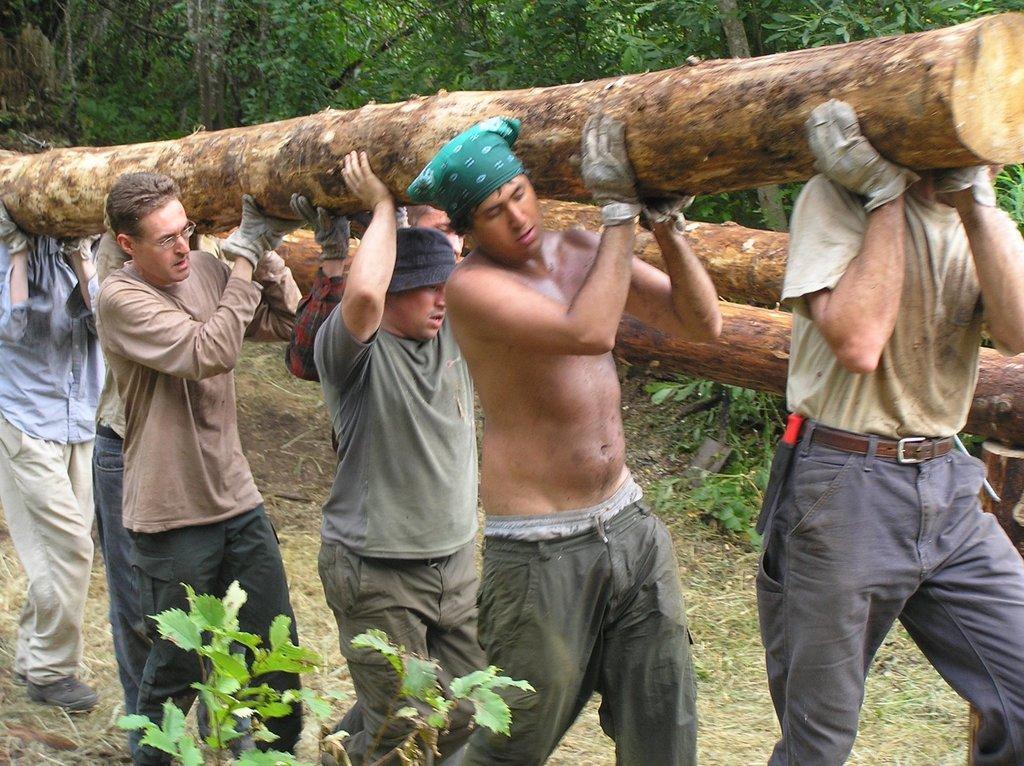In one or two sentences, can you explain what this image depicts? In the image there are few men walking on the land carrying huge wooden logs, in the back there are trees on the land, in the front there is a plant. 